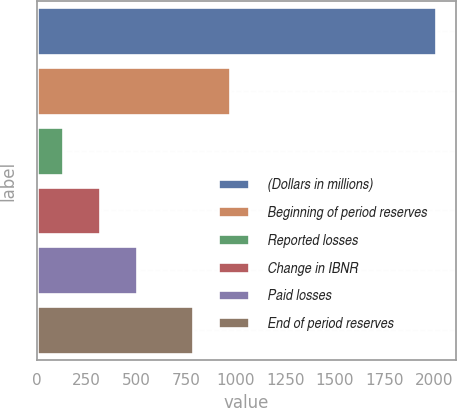<chart> <loc_0><loc_0><loc_500><loc_500><bar_chart><fcel>(Dollars in millions)<fcel>Beginning of period reserves<fcel>Reported losses<fcel>Change in IBNR<fcel>Paid losses<fcel>End of period reserves<nl><fcel>2008<fcel>974.53<fcel>130.7<fcel>318.43<fcel>506.16<fcel>786.8<nl></chart> 